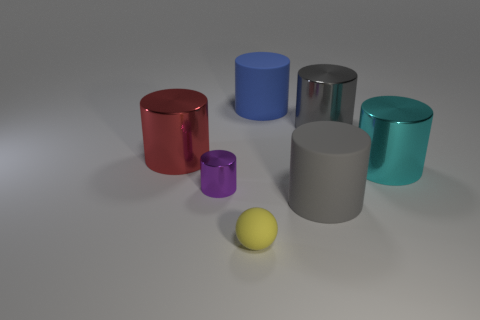Are there more large purple matte spheres than small metal things?
Provide a succinct answer. No. What number of things are red metal cylinders or gray matte objects?
Your answer should be very brief. 2. Is the shape of the gray thing that is in front of the big cyan object the same as  the purple thing?
Keep it short and to the point. Yes. What is the color of the big rubber cylinder to the left of the gray object that is on the left side of the gray shiny cylinder?
Offer a very short reply. Blue. Are there fewer small metal cylinders than small purple rubber balls?
Offer a very short reply. No. Are there any tiny green cubes made of the same material as the cyan object?
Give a very brief answer. No. There is a large cyan object; is it the same shape as the gray thing behind the small cylinder?
Give a very brief answer. Yes. There is a small rubber sphere; are there any blue cylinders behind it?
Offer a very short reply. Yes. What number of large cyan things are the same shape as the large gray shiny object?
Ensure brevity in your answer.  1. Is the material of the tiny yellow sphere the same as the thing left of the tiny metal thing?
Keep it short and to the point. No. 